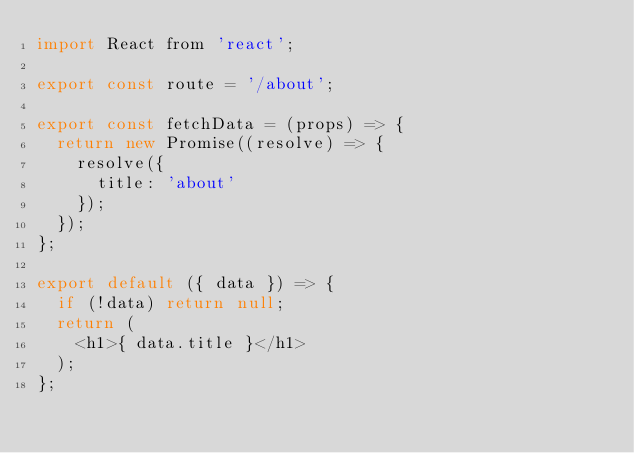<code> <loc_0><loc_0><loc_500><loc_500><_JavaScript_>import React from 'react';

export const route = '/about';

export const fetchData = (props) => {
  return new Promise((resolve) => {
    resolve({
      title: 'about'
    });
  });
};

export default ({ data }) => {
  if (!data) return null;
  return (
    <h1>{ data.title }</h1>
  );
};
</code> 